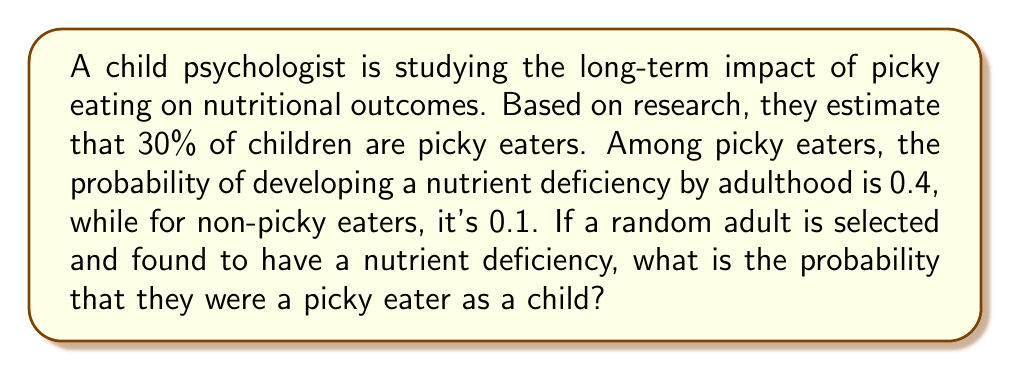Can you answer this question? Let's approach this using Bayes' theorem:

1) Define events:
   P = Person was a picky eater as a child
   D = Person has a nutrient deficiency as an adult

2) Given probabilities:
   P(P) = 0.30 (30% of children are picky eaters)
   P(D|P) = 0.40 (40% of picky eaters develop a deficiency)
   P(D|not P) = 0.10 (10% of non-picky eaters develop a deficiency)

3) We need to find P(P|D) using Bayes' theorem:

   $$P(P|D) = \frac{P(D|P) \cdot P(P)}{P(D)}$$

4) Calculate P(D) using the law of total probability:
   
   $$P(D) = P(D|P) \cdot P(P) + P(D|not P) \cdot P(not P)$$
   $$P(D) = 0.40 \cdot 0.30 + 0.10 \cdot 0.70 = 0.12 + 0.07 = 0.19$$

5) Now we can apply Bayes' theorem:

   $$P(P|D) = \frac{0.40 \cdot 0.30}{0.19} = \frac{0.12}{0.19} \approx 0.6316$$

6) Convert to a percentage: 0.6316 * 100 ≈ 63.16%
Answer: 63.16% 